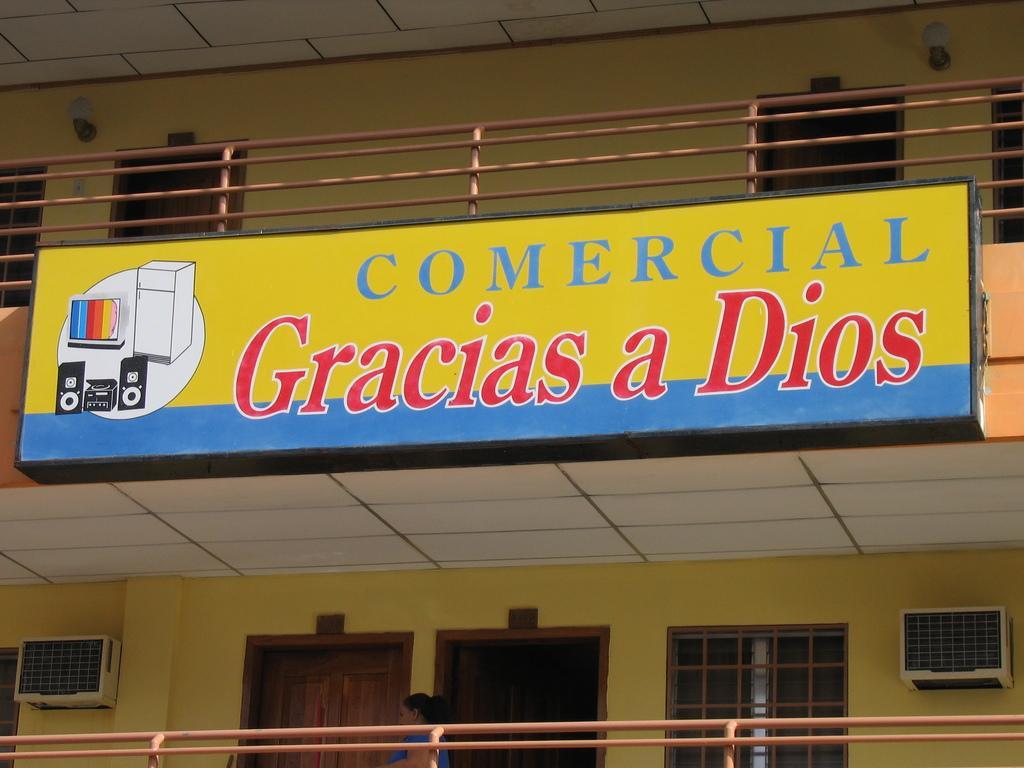Could you give a brief overview of what you see in this image? In this image I can see a building, the railing, few doors, few windows and a huge board which is yellow, blue, black, red and white in color to the building. 